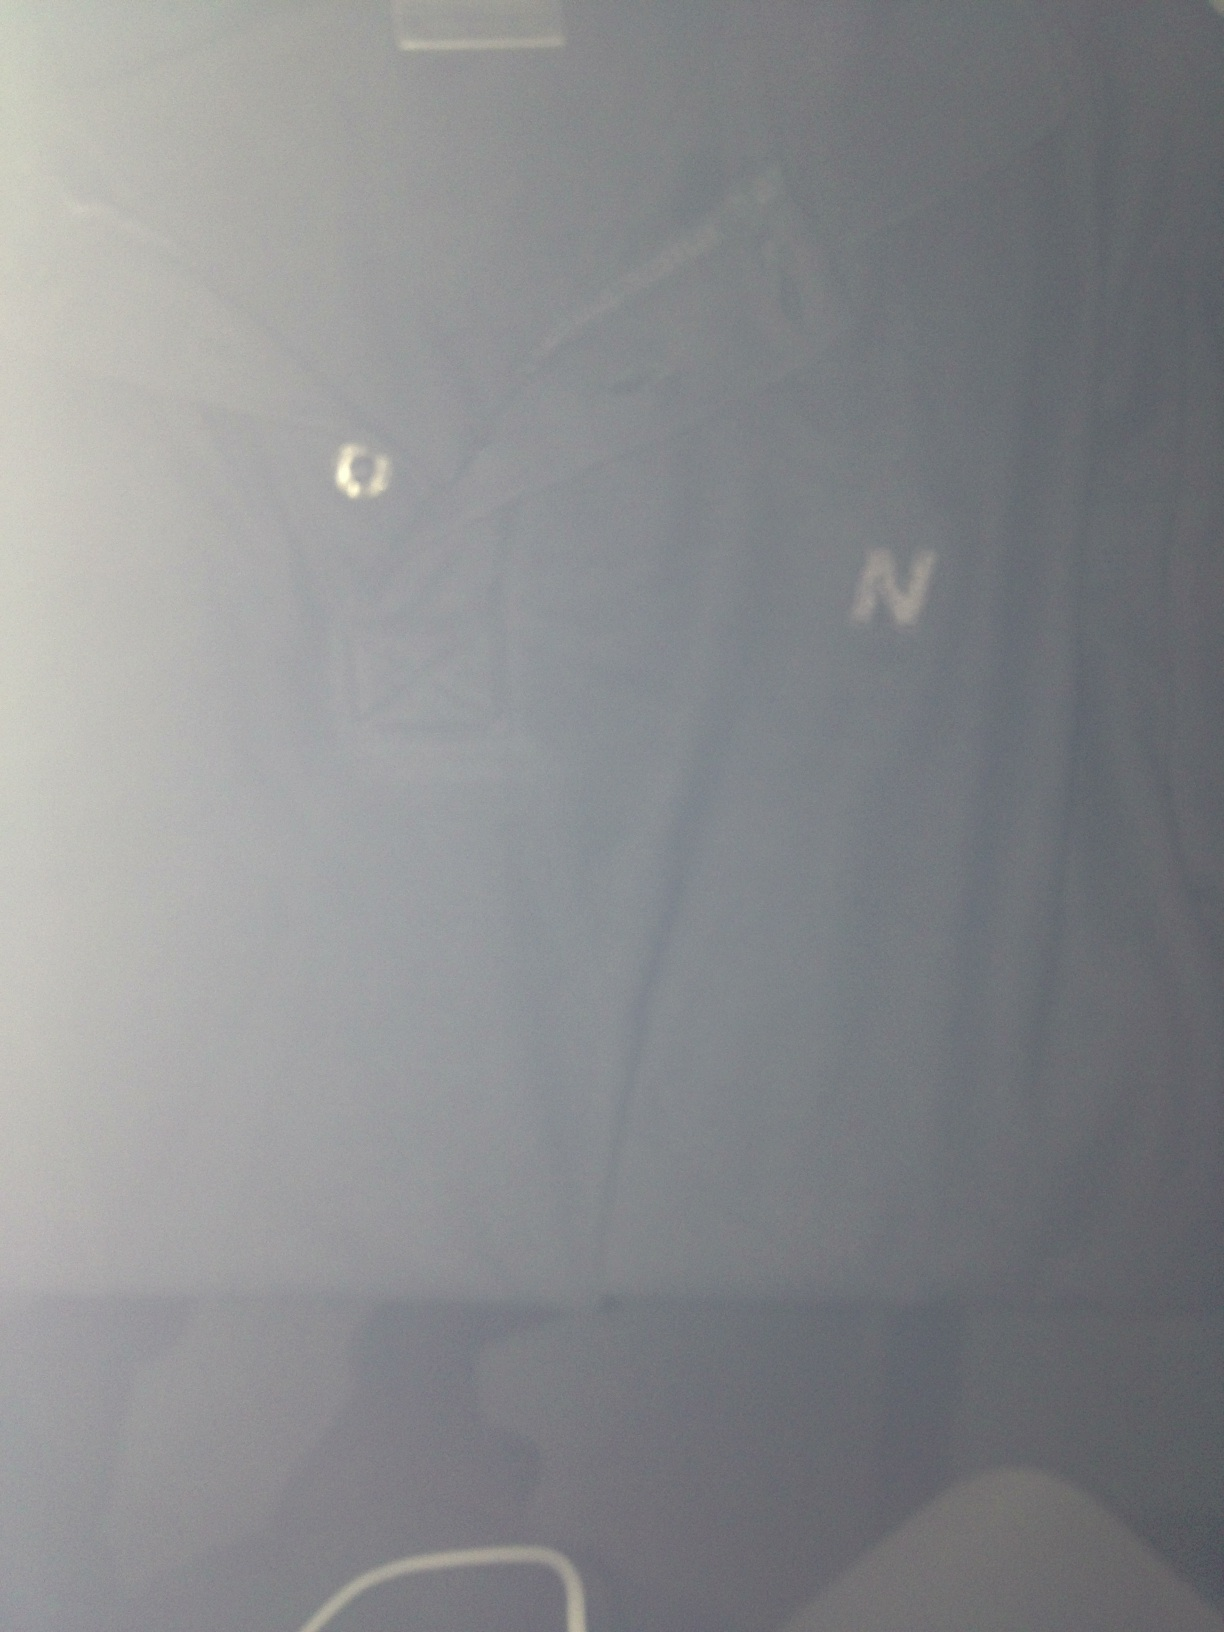This tee shirt looks interesting. Can you fabricate a detailed and creative backstory involving this shirt in a science fiction universe? In the year 2147, this seemingly ordinary dark blue tee shirt became a relic of great historical importance. Crafted from a blend of interstellar fibers, it once belonged to Captain Elena Starfire, the renowned commander of the spaceship Nebula. This shirt was worn during her first encounter with the Andromedans, an enigmatic alien species. The 'N' emblem did not stand merely for a brand, but for 'Nebula,' the vessel she commanded. In a pivotal moment of diplomacy, Captain Starfire, donning this very shirt, brokered a peace treaty that ended years of intergalactic conflict. The shirt retained residues of Andromedan energy, giving it a subtle, ethereal glow that only those attuned to cosmic energies could see. As time passed, it became an artifact revered in the Galactic Museum of History, symbolizing peace, unity, and the bravery of one remarkable woman. 